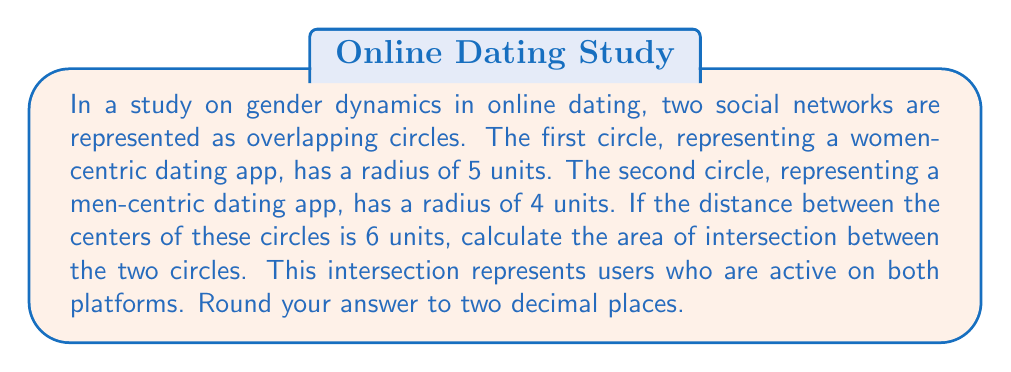Give your solution to this math problem. To solve this problem, we'll use the formula for the area of intersection between two circles. Let's approach this step-by-step:

1) First, we need to calculate the distance from the center of each circle to the line of intersection. We can do this using the formula:

   $$d_1 = \frac{r_1^2 - r_2^2 + d^2}{2d}$$
   $$d_2 = d - d_1$$

   Where $r_1$ = 5 (radius of first circle), $r_2$ = 4 (radius of second circle), and $d$ = 6 (distance between centers)

2) Let's calculate $d_1$:
   $$d_1 = \frac{5^2 - 4^2 + 6^2}{2(6)} = \frac{25 - 16 + 36}{12} = \frac{45}{12} = 3.75$$

3) Now $d_2$:
   $$d_2 = 6 - 3.75 = 2.25$$

4) Next, we need to calculate the central angles of the sectors in each circle:

   $$\theta_1 = 2 \arccos(\frac{d_1}{r_1}) = 2 \arccos(\frac{3.75}{5})$$
   $$\theta_2 = 2 \arccos(\frac{d_2}{r_2}) = 2 \arccos(\frac{2.25}{4})$$

5) Now we can calculate the area of intersection using the formula:

   $$A = r_1^2 \arccos(\frac{d_1}{r_1}) + r_2^2 \arccos(\frac{d_2}{r_2}) - d_1\sqrt{r_1^2 - d_1^2} - d_2\sqrt{r_2^2 - d_2^2}$$

6) Plugging in our values:

   $$A = 5^2 \arccos(\frac{3.75}{5}) + 4^2 \arccos(\frac{2.25}{4}) - 3.75\sqrt{5^2 - 3.75^2} - 2.25\sqrt{4^2 - 2.25^2}$$

7) Calculating this (using a calculator for the trigonometric functions and square roots):

   $$A \approx 25(0.8480) + 16(1.0472) - 3.75(3.3541) - 2.25(3.3541)$$
   $$A \approx 21.2000 + 16.7552 - 12.5779 - 7.5467$$
   $$A \approx 17.8306$$

8) Rounding to two decimal places:

   $$A \approx 17.83$$
Answer: 17.83 square units 